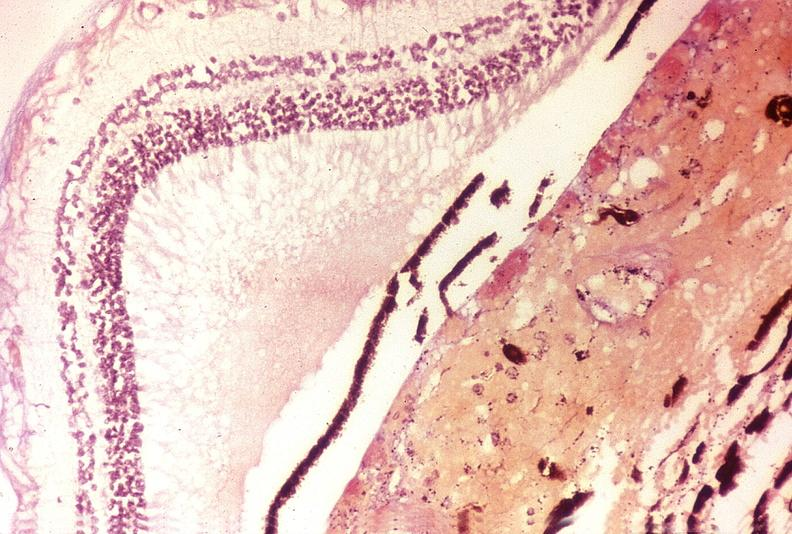s eye present?
Answer the question using a single word or phrase. Yes 